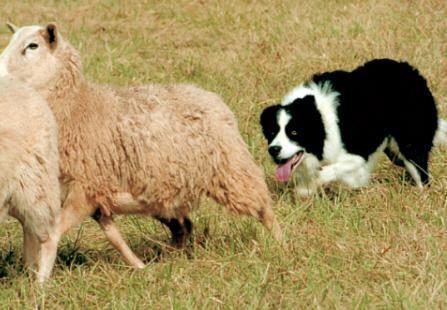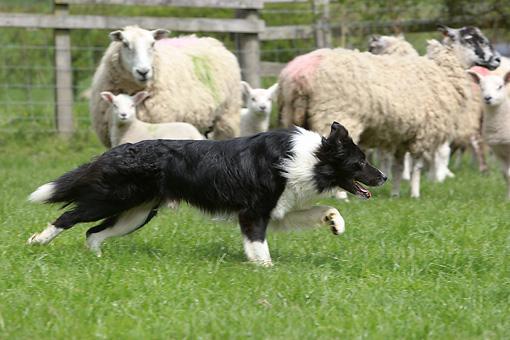The first image is the image on the left, the second image is the image on the right. Evaluate the accuracy of this statement regarding the images: "A dog is positioned closest to the front of an image, with multiple sheep in the back.". Is it true? Answer yes or no. Yes. The first image is the image on the left, the second image is the image on the right. Assess this claim about the two images: "In one of the images, there are exactly three sheep.". Correct or not? Answer yes or no. No. 